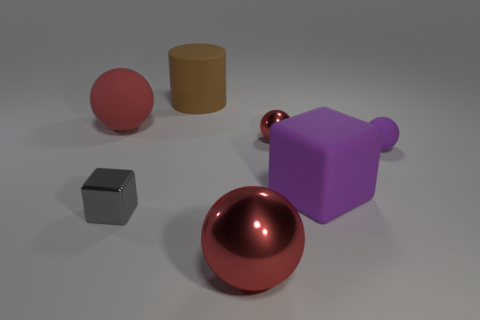How many red balls must be subtracted to get 1 red balls? 2 Subtract all red spheres. How many spheres are left? 1 Add 3 big matte cylinders. How many objects exist? 10 Subtract all purple balls. How many balls are left? 3 Subtract all cubes. How many objects are left? 5 Add 2 brown cylinders. How many brown cylinders are left? 3 Add 1 large rubber cylinders. How many large rubber cylinders exist? 2 Subtract 1 gray cubes. How many objects are left? 6 Subtract 1 blocks. How many blocks are left? 1 Subtract all cyan cylinders. Subtract all cyan balls. How many cylinders are left? 1 